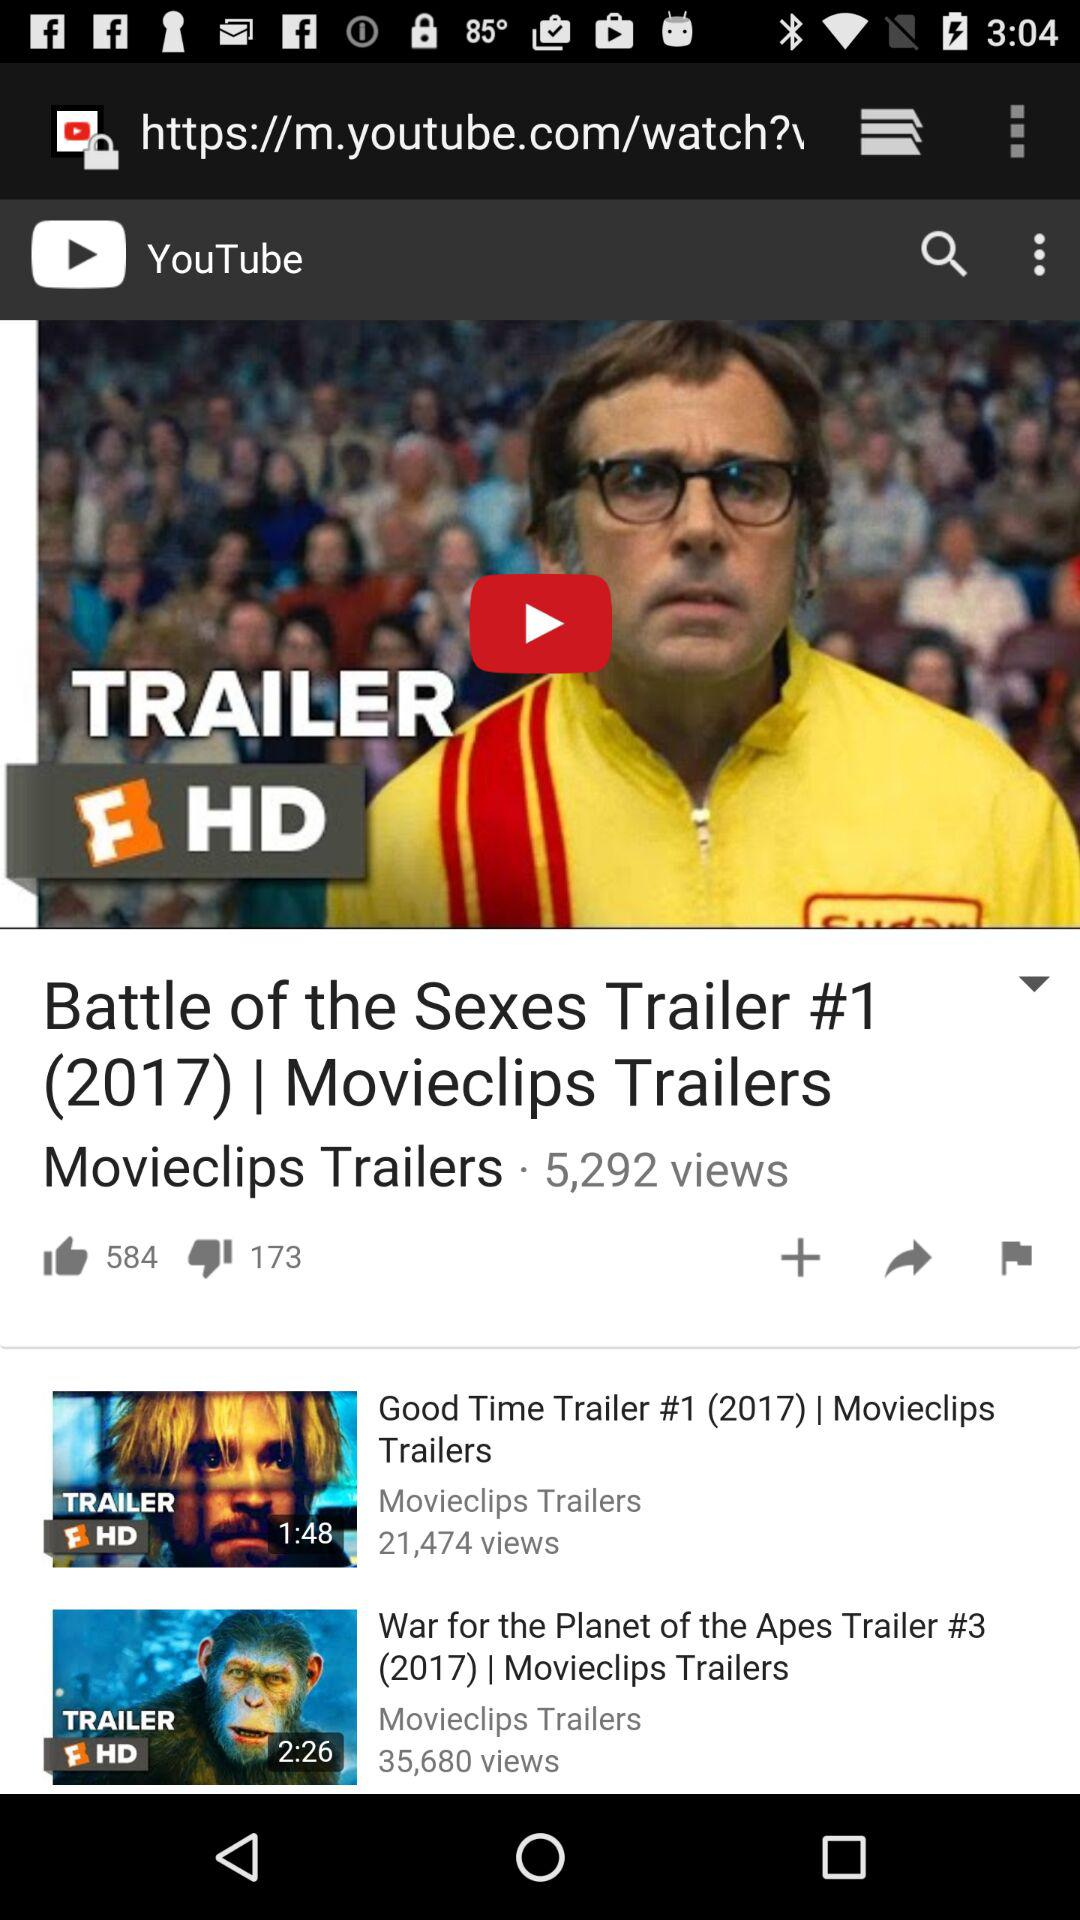What is the length of the "Good Time Trailer"? The length of the "Good Time Trailer" is 1 minute and 48 seconds. 